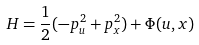Convert formula to latex. <formula><loc_0><loc_0><loc_500><loc_500>H = \frac { 1 } { 2 } ( - p _ { u } ^ { 2 } + p _ { x } ^ { 2 } ) + \Phi ( u , x )</formula> 